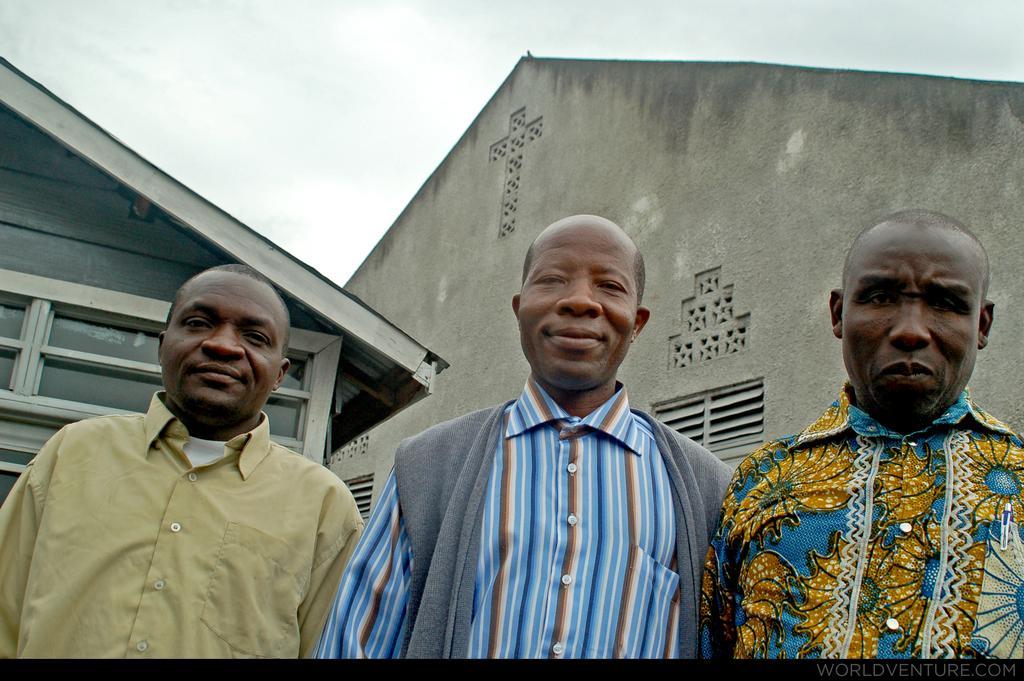Can you describe this image briefly? In this image there are three man standing, in the background there is a house and a sky. 